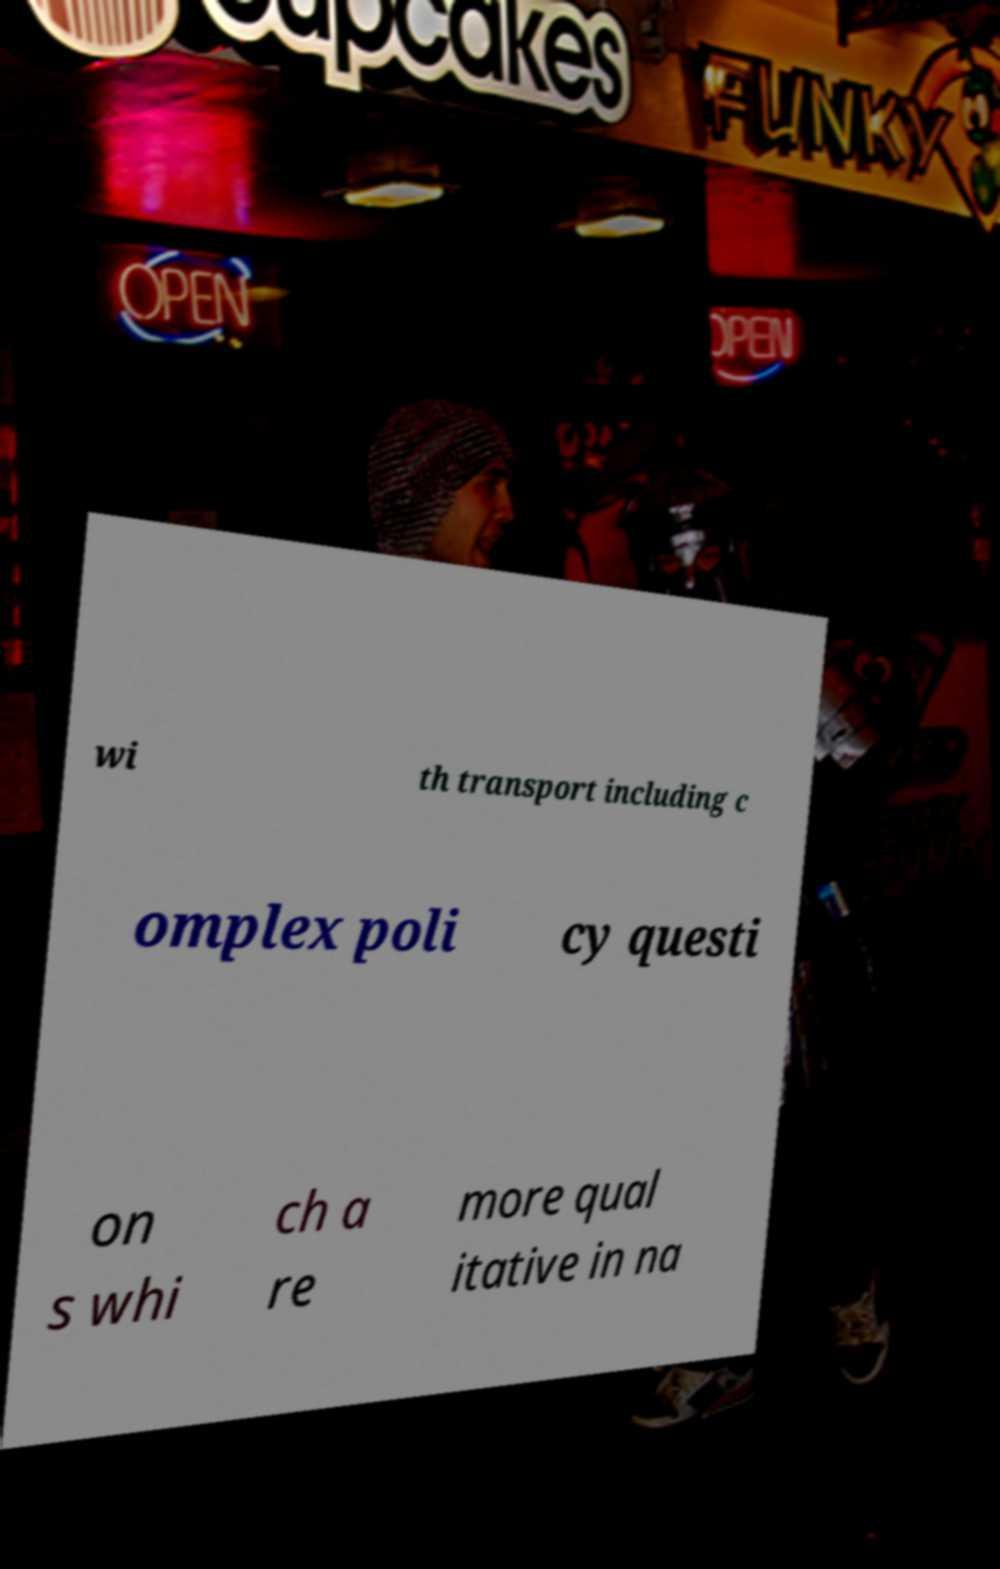I need the written content from this picture converted into text. Can you do that? wi th transport including c omplex poli cy questi on s whi ch a re more qual itative in na 